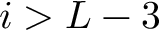Convert formula to latex. <formula><loc_0><loc_0><loc_500><loc_500>i > L - 3</formula> 